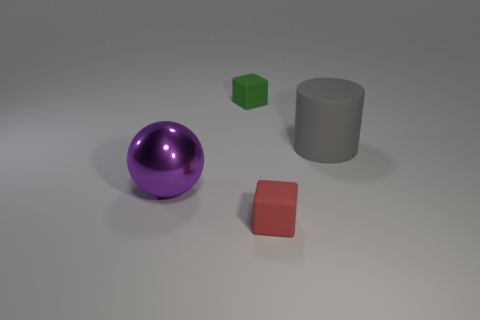Imagine these objects are part of a simple physics puzzle game. What could be a rule or objective involving these shapes? In a physics puzzle game setting, one possible rule could be to move the shapes to specific zones based on their colors or shapes. For example, the objective might be to roll the purple sphere into a circular receptacle, stack the green cube on a platform of the same shape, and slide the red square into a square-shaped niche, all while overcoming obstacles and using problem-solving skills. 